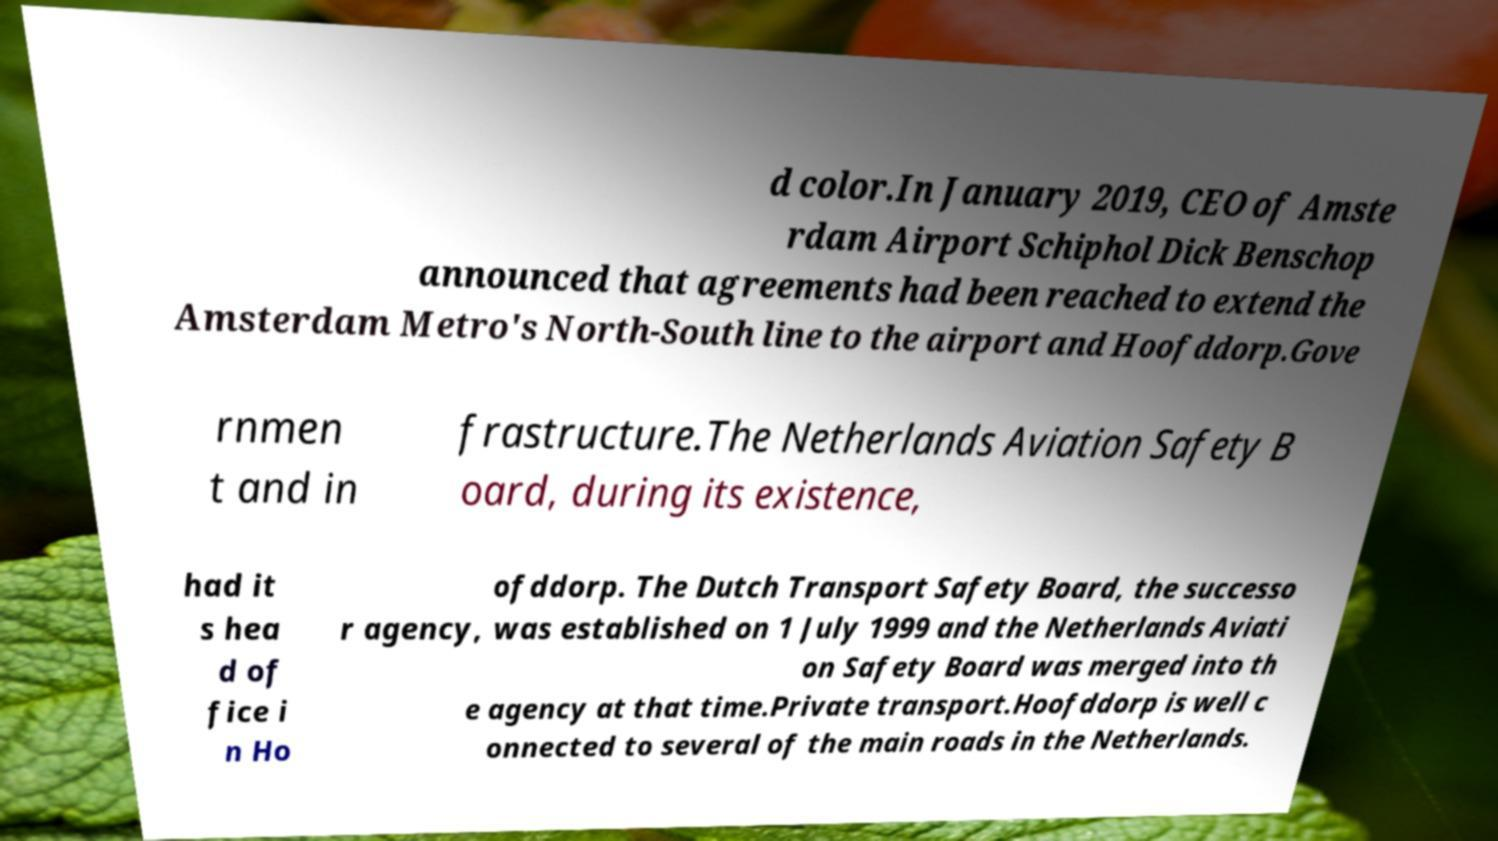Could you extract and type out the text from this image? d color.In January 2019, CEO of Amste rdam Airport Schiphol Dick Benschop announced that agreements had been reached to extend the Amsterdam Metro's North-South line to the airport and Hoofddorp.Gove rnmen t and in frastructure.The Netherlands Aviation Safety B oard, during its existence, had it s hea d of fice i n Ho ofddorp. The Dutch Transport Safety Board, the successo r agency, was established on 1 July 1999 and the Netherlands Aviati on Safety Board was merged into th e agency at that time.Private transport.Hoofddorp is well c onnected to several of the main roads in the Netherlands. 